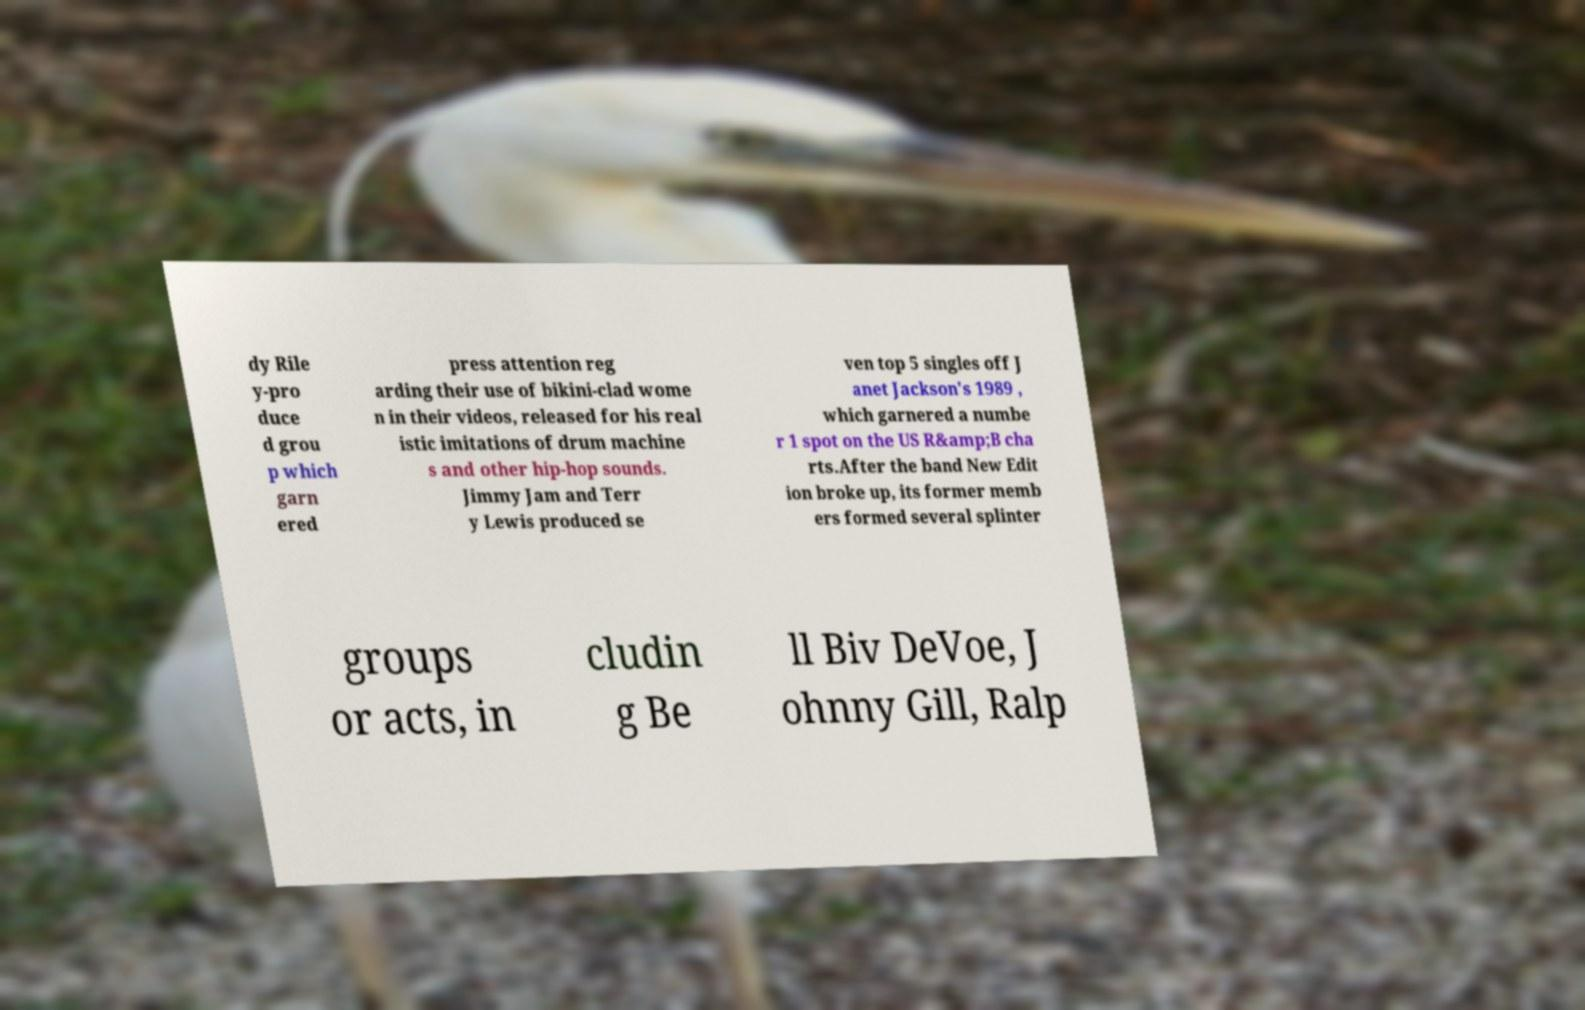For documentation purposes, I need the text within this image transcribed. Could you provide that? dy Rile y-pro duce d grou p which garn ered press attention reg arding their use of bikini-clad wome n in their videos, released for his real istic imitations of drum machine s and other hip-hop sounds. Jimmy Jam and Terr y Lewis produced se ven top 5 singles off J anet Jackson's 1989 , which garnered a numbe r 1 spot on the US R&amp;B cha rts.After the band New Edit ion broke up, its former memb ers formed several splinter groups or acts, in cludin g Be ll Biv DeVoe, J ohnny Gill, Ralp 